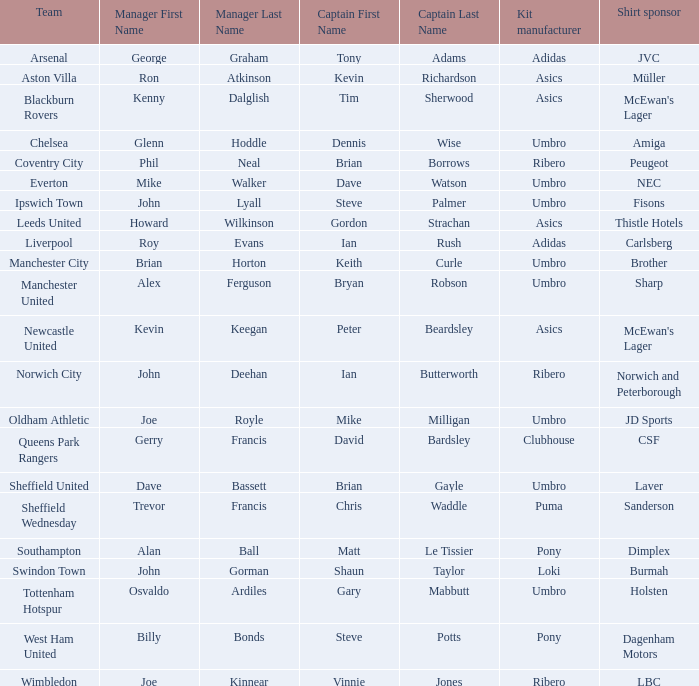Which team has george graham as the manager? Arsenal. 